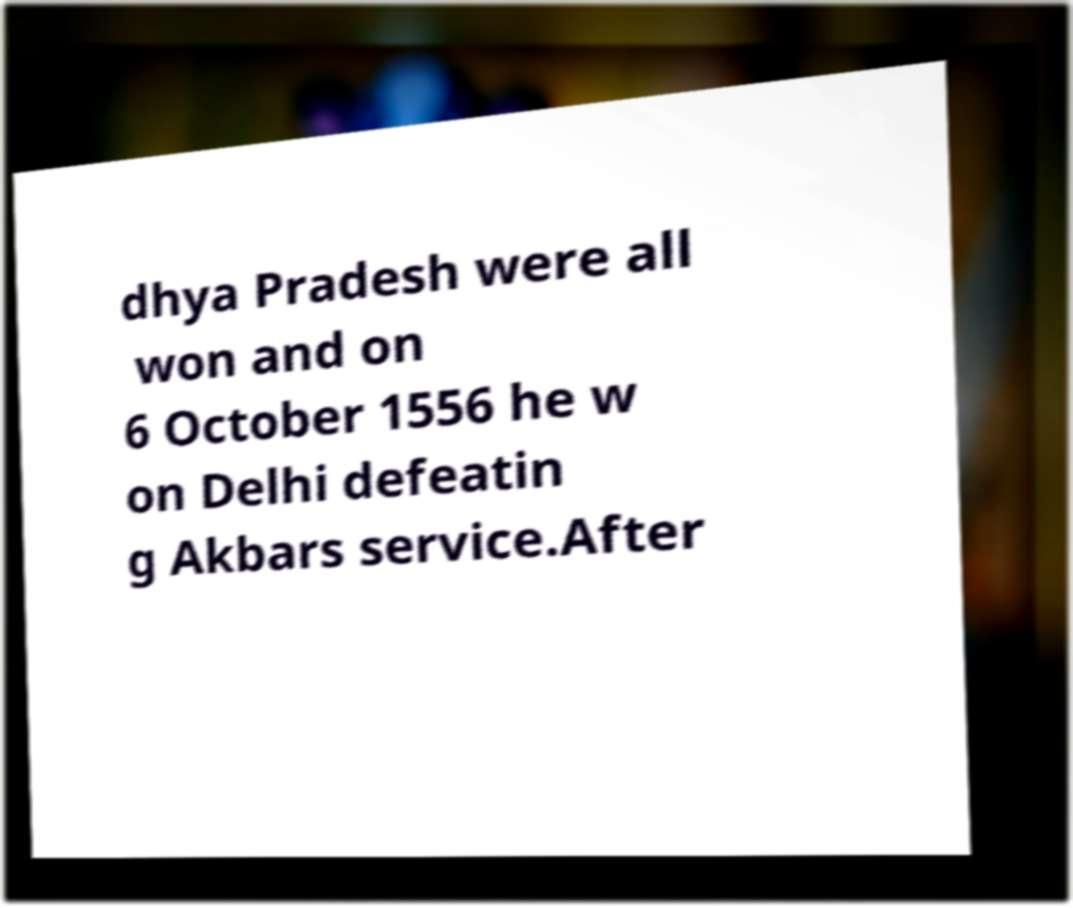Please read and relay the text visible in this image. What does it say? dhya Pradesh were all won and on 6 October 1556 he w on Delhi defeatin g Akbars service.After 